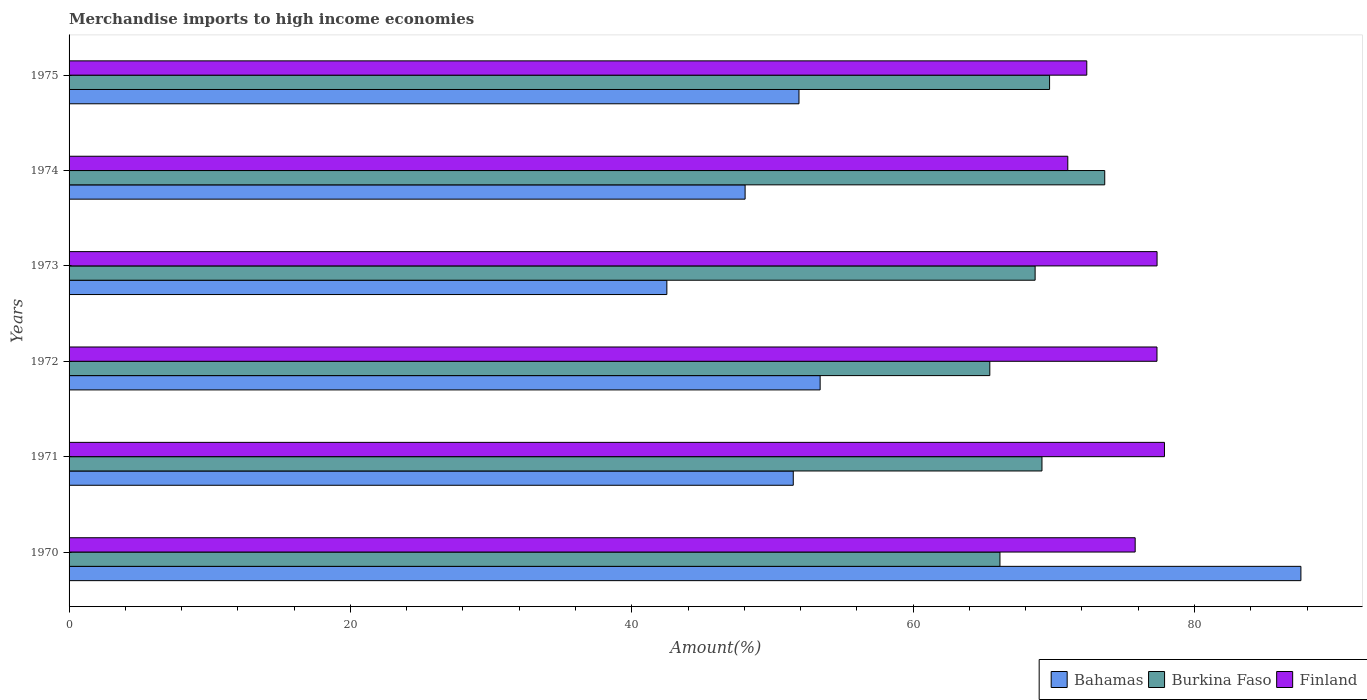How many different coloured bars are there?
Offer a terse response. 3. How many groups of bars are there?
Give a very brief answer. 6. What is the percentage of amount earned from merchandise imports in Bahamas in 1970?
Give a very brief answer. 87.57. Across all years, what is the maximum percentage of amount earned from merchandise imports in Bahamas?
Offer a terse response. 87.57. Across all years, what is the minimum percentage of amount earned from merchandise imports in Burkina Faso?
Offer a terse response. 65.45. In which year was the percentage of amount earned from merchandise imports in Finland maximum?
Keep it short and to the point. 1971. What is the total percentage of amount earned from merchandise imports in Finland in the graph?
Your answer should be very brief. 451.67. What is the difference between the percentage of amount earned from merchandise imports in Burkina Faso in 1973 and that in 1975?
Your answer should be compact. -1.03. What is the difference between the percentage of amount earned from merchandise imports in Burkina Faso in 1970 and the percentage of amount earned from merchandise imports in Finland in 1975?
Provide a short and direct response. -6.17. What is the average percentage of amount earned from merchandise imports in Burkina Faso per year?
Offer a very short reply. 68.8. In the year 1974, what is the difference between the percentage of amount earned from merchandise imports in Finland and percentage of amount earned from merchandise imports in Bahamas?
Offer a very short reply. 22.94. What is the ratio of the percentage of amount earned from merchandise imports in Burkina Faso in 1973 to that in 1974?
Provide a succinct answer. 0.93. Is the difference between the percentage of amount earned from merchandise imports in Finland in 1970 and 1973 greater than the difference between the percentage of amount earned from merchandise imports in Bahamas in 1970 and 1973?
Provide a short and direct response. No. What is the difference between the highest and the second highest percentage of amount earned from merchandise imports in Bahamas?
Your response must be concise. 34.18. What is the difference between the highest and the lowest percentage of amount earned from merchandise imports in Burkina Faso?
Ensure brevity in your answer.  8.17. Is the sum of the percentage of amount earned from merchandise imports in Finland in 1971 and 1972 greater than the maximum percentage of amount earned from merchandise imports in Bahamas across all years?
Offer a terse response. Yes. What does the 1st bar from the top in 1971 represents?
Keep it short and to the point. Finland. How many bars are there?
Your answer should be compact. 18. Are all the bars in the graph horizontal?
Make the answer very short. Yes. How many years are there in the graph?
Provide a succinct answer. 6. What is the difference between two consecutive major ticks on the X-axis?
Provide a succinct answer. 20. Are the values on the major ticks of X-axis written in scientific E-notation?
Give a very brief answer. No. Does the graph contain grids?
Offer a terse response. No. Where does the legend appear in the graph?
Offer a terse response. Bottom right. How many legend labels are there?
Your response must be concise. 3. How are the legend labels stacked?
Offer a terse response. Horizontal. What is the title of the graph?
Make the answer very short. Merchandise imports to high income economies. Does "Zambia" appear as one of the legend labels in the graph?
Your answer should be very brief. No. What is the label or title of the X-axis?
Your response must be concise. Amount(%). What is the label or title of the Y-axis?
Keep it short and to the point. Years. What is the Amount(%) of Bahamas in 1970?
Make the answer very short. 87.57. What is the Amount(%) of Burkina Faso in 1970?
Offer a terse response. 66.17. What is the Amount(%) of Finland in 1970?
Keep it short and to the point. 75.79. What is the Amount(%) in Bahamas in 1971?
Your response must be concise. 51.48. What is the Amount(%) of Burkina Faso in 1971?
Offer a very short reply. 69.16. What is the Amount(%) in Finland in 1971?
Your answer should be very brief. 77.87. What is the Amount(%) of Bahamas in 1972?
Offer a very short reply. 53.39. What is the Amount(%) in Burkina Faso in 1972?
Make the answer very short. 65.45. What is the Amount(%) of Finland in 1972?
Give a very brief answer. 77.34. What is the Amount(%) of Bahamas in 1973?
Make the answer very short. 42.49. What is the Amount(%) of Burkina Faso in 1973?
Make the answer very short. 68.67. What is the Amount(%) of Finland in 1973?
Your answer should be compact. 77.34. What is the Amount(%) of Bahamas in 1974?
Give a very brief answer. 48.06. What is the Amount(%) in Burkina Faso in 1974?
Your response must be concise. 73.62. What is the Amount(%) of Finland in 1974?
Ensure brevity in your answer.  71. What is the Amount(%) of Bahamas in 1975?
Give a very brief answer. 51.89. What is the Amount(%) in Burkina Faso in 1975?
Your answer should be compact. 69.7. What is the Amount(%) in Finland in 1975?
Offer a very short reply. 72.35. Across all years, what is the maximum Amount(%) of Bahamas?
Provide a succinct answer. 87.57. Across all years, what is the maximum Amount(%) in Burkina Faso?
Keep it short and to the point. 73.62. Across all years, what is the maximum Amount(%) in Finland?
Give a very brief answer. 77.87. Across all years, what is the minimum Amount(%) in Bahamas?
Provide a short and direct response. 42.49. Across all years, what is the minimum Amount(%) of Burkina Faso?
Give a very brief answer. 65.45. Across all years, what is the minimum Amount(%) in Finland?
Keep it short and to the point. 71. What is the total Amount(%) of Bahamas in the graph?
Your answer should be compact. 334.87. What is the total Amount(%) in Burkina Faso in the graph?
Ensure brevity in your answer.  412.78. What is the total Amount(%) in Finland in the graph?
Your answer should be compact. 451.67. What is the difference between the Amount(%) of Bahamas in 1970 and that in 1971?
Your answer should be compact. 36.09. What is the difference between the Amount(%) of Burkina Faso in 1970 and that in 1971?
Provide a succinct answer. -2.99. What is the difference between the Amount(%) of Finland in 1970 and that in 1971?
Offer a very short reply. -2.08. What is the difference between the Amount(%) in Bahamas in 1970 and that in 1972?
Your response must be concise. 34.18. What is the difference between the Amount(%) of Burkina Faso in 1970 and that in 1972?
Offer a very short reply. 0.72. What is the difference between the Amount(%) in Finland in 1970 and that in 1972?
Your response must be concise. -1.55. What is the difference between the Amount(%) in Bahamas in 1970 and that in 1973?
Make the answer very short. 45.07. What is the difference between the Amount(%) in Burkina Faso in 1970 and that in 1973?
Ensure brevity in your answer.  -2.5. What is the difference between the Amount(%) in Finland in 1970 and that in 1973?
Offer a terse response. -1.56. What is the difference between the Amount(%) in Bahamas in 1970 and that in 1974?
Your answer should be compact. 39.51. What is the difference between the Amount(%) of Burkina Faso in 1970 and that in 1974?
Your response must be concise. -7.45. What is the difference between the Amount(%) in Finland in 1970 and that in 1974?
Give a very brief answer. 4.79. What is the difference between the Amount(%) in Bahamas in 1970 and that in 1975?
Offer a very short reply. 35.68. What is the difference between the Amount(%) of Burkina Faso in 1970 and that in 1975?
Provide a short and direct response. -3.53. What is the difference between the Amount(%) of Finland in 1970 and that in 1975?
Keep it short and to the point. 3.44. What is the difference between the Amount(%) of Bahamas in 1971 and that in 1972?
Make the answer very short. -1.91. What is the difference between the Amount(%) of Burkina Faso in 1971 and that in 1972?
Make the answer very short. 3.71. What is the difference between the Amount(%) in Finland in 1971 and that in 1972?
Offer a very short reply. 0.53. What is the difference between the Amount(%) in Bahamas in 1971 and that in 1973?
Offer a very short reply. 8.99. What is the difference between the Amount(%) in Burkina Faso in 1971 and that in 1973?
Your response must be concise. 0.49. What is the difference between the Amount(%) in Finland in 1971 and that in 1973?
Give a very brief answer. 0.53. What is the difference between the Amount(%) of Bahamas in 1971 and that in 1974?
Provide a short and direct response. 3.42. What is the difference between the Amount(%) in Burkina Faso in 1971 and that in 1974?
Give a very brief answer. -4.46. What is the difference between the Amount(%) of Finland in 1971 and that in 1974?
Ensure brevity in your answer.  6.87. What is the difference between the Amount(%) in Bahamas in 1971 and that in 1975?
Offer a terse response. -0.41. What is the difference between the Amount(%) of Burkina Faso in 1971 and that in 1975?
Your response must be concise. -0.54. What is the difference between the Amount(%) of Finland in 1971 and that in 1975?
Ensure brevity in your answer.  5.52. What is the difference between the Amount(%) in Bahamas in 1972 and that in 1973?
Your response must be concise. 10.9. What is the difference between the Amount(%) of Burkina Faso in 1972 and that in 1973?
Ensure brevity in your answer.  -3.22. What is the difference between the Amount(%) in Finland in 1972 and that in 1973?
Your answer should be compact. -0.01. What is the difference between the Amount(%) of Bahamas in 1972 and that in 1974?
Offer a very short reply. 5.33. What is the difference between the Amount(%) in Burkina Faso in 1972 and that in 1974?
Offer a very short reply. -8.17. What is the difference between the Amount(%) of Finland in 1972 and that in 1974?
Keep it short and to the point. 6.34. What is the difference between the Amount(%) in Bahamas in 1972 and that in 1975?
Offer a very short reply. 1.5. What is the difference between the Amount(%) in Burkina Faso in 1972 and that in 1975?
Your answer should be compact. -4.25. What is the difference between the Amount(%) in Finland in 1972 and that in 1975?
Provide a short and direct response. 4.99. What is the difference between the Amount(%) of Bahamas in 1973 and that in 1974?
Provide a succinct answer. -5.56. What is the difference between the Amount(%) in Burkina Faso in 1973 and that in 1974?
Your answer should be compact. -4.95. What is the difference between the Amount(%) of Finland in 1973 and that in 1974?
Give a very brief answer. 6.35. What is the difference between the Amount(%) of Bahamas in 1973 and that in 1975?
Your answer should be very brief. -9.39. What is the difference between the Amount(%) in Burkina Faso in 1973 and that in 1975?
Your answer should be compact. -1.03. What is the difference between the Amount(%) in Finland in 1973 and that in 1975?
Your answer should be very brief. 5. What is the difference between the Amount(%) of Bahamas in 1974 and that in 1975?
Your response must be concise. -3.83. What is the difference between the Amount(%) in Burkina Faso in 1974 and that in 1975?
Make the answer very short. 3.92. What is the difference between the Amount(%) of Finland in 1974 and that in 1975?
Make the answer very short. -1.35. What is the difference between the Amount(%) in Bahamas in 1970 and the Amount(%) in Burkina Faso in 1971?
Provide a succinct answer. 18.41. What is the difference between the Amount(%) in Bahamas in 1970 and the Amount(%) in Finland in 1971?
Make the answer very short. 9.7. What is the difference between the Amount(%) in Burkina Faso in 1970 and the Amount(%) in Finland in 1971?
Keep it short and to the point. -11.69. What is the difference between the Amount(%) of Bahamas in 1970 and the Amount(%) of Burkina Faso in 1972?
Ensure brevity in your answer.  22.11. What is the difference between the Amount(%) of Bahamas in 1970 and the Amount(%) of Finland in 1972?
Keep it short and to the point. 10.23. What is the difference between the Amount(%) of Burkina Faso in 1970 and the Amount(%) of Finland in 1972?
Your answer should be compact. -11.16. What is the difference between the Amount(%) of Bahamas in 1970 and the Amount(%) of Burkina Faso in 1973?
Offer a terse response. 18.89. What is the difference between the Amount(%) in Bahamas in 1970 and the Amount(%) in Finland in 1973?
Give a very brief answer. 10.22. What is the difference between the Amount(%) in Burkina Faso in 1970 and the Amount(%) in Finland in 1973?
Give a very brief answer. -11.17. What is the difference between the Amount(%) of Bahamas in 1970 and the Amount(%) of Burkina Faso in 1974?
Your answer should be compact. 13.94. What is the difference between the Amount(%) of Bahamas in 1970 and the Amount(%) of Finland in 1974?
Make the answer very short. 16.57. What is the difference between the Amount(%) of Burkina Faso in 1970 and the Amount(%) of Finland in 1974?
Offer a terse response. -4.82. What is the difference between the Amount(%) of Bahamas in 1970 and the Amount(%) of Burkina Faso in 1975?
Ensure brevity in your answer.  17.87. What is the difference between the Amount(%) in Bahamas in 1970 and the Amount(%) in Finland in 1975?
Keep it short and to the point. 15.22. What is the difference between the Amount(%) of Burkina Faso in 1970 and the Amount(%) of Finland in 1975?
Provide a short and direct response. -6.17. What is the difference between the Amount(%) in Bahamas in 1971 and the Amount(%) in Burkina Faso in 1972?
Ensure brevity in your answer.  -13.97. What is the difference between the Amount(%) of Bahamas in 1971 and the Amount(%) of Finland in 1972?
Your answer should be compact. -25.86. What is the difference between the Amount(%) in Burkina Faso in 1971 and the Amount(%) in Finland in 1972?
Offer a terse response. -8.18. What is the difference between the Amount(%) of Bahamas in 1971 and the Amount(%) of Burkina Faso in 1973?
Your answer should be compact. -17.19. What is the difference between the Amount(%) of Bahamas in 1971 and the Amount(%) of Finland in 1973?
Your answer should be very brief. -25.86. What is the difference between the Amount(%) of Burkina Faso in 1971 and the Amount(%) of Finland in 1973?
Keep it short and to the point. -8.18. What is the difference between the Amount(%) of Bahamas in 1971 and the Amount(%) of Burkina Faso in 1974?
Provide a succinct answer. -22.14. What is the difference between the Amount(%) of Bahamas in 1971 and the Amount(%) of Finland in 1974?
Make the answer very short. -19.52. What is the difference between the Amount(%) in Burkina Faso in 1971 and the Amount(%) in Finland in 1974?
Provide a short and direct response. -1.84. What is the difference between the Amount(%) in Bahamas in 1971 and the Amount(%) in Burkina Faso in 1975?
Your answer should be compact. -18.22. What is the difference between the Amount(%) of Bahamas in 1971 and the Amount(%) of Finland in 1975?
Make the answer very short. -20.87. What is the difference between the Amount(%) of Burkina Faso in 1971 and the Amount(%) of Finland in 1975?
Offer a terse response. -3.19. What is the difference between the Amount(%) in Bahamas in 1972 and the Amount(%) in Burkina Faso in 1973?
Give a very brief answer. -15.28. What is the difference between the Amount(%) in Bahamas in 1972 and the Amount(%) in Finland in 1973?
Provide a short and direct response. -23.95. What is the difference between the Amount(%) of Burkina Faso in 1972 and the Amount(%) of Finland in 1973?
Make the answer very short. -11.89. What is the difference between the Amount(%) of Bahamas in 1972 and the Amount(%) of Burkina Faso in 1974?
Ensure brevity in your answer.  -20.23. What is the difference between the Amount(%) of Bahamas in 1972 and the Amount(%) of Finland in 1974?
Offer a very short reply. -17.6. What is the difference between the Amount(%) of Burkina Faso in 1972 and the Amount(%) of Finland in 1974?
Your response must be concise. -5.54. What is the difference between the Amount(%) in Bahamas in 1972 and the Amount(%) in Burkina Faso in 1975?
Your answer should be very brief. -16.31. What is the difference between the Amount(%) of Bahamas in 1972 and the Amount(%) of Finland in 1975?
Your answer should be compact. -18.95. What is the difference between the Amount(%) in Burkina Faso in 1972 and the Amount(%) in Finland in 1975?
Give a very brief answer. -6.89. What is the difference between the Amount(%) in Bahamas in 1973 and the Amount(%) in Burkina Faso in 1974?
Offer a very short reply. -31.13. What is the difference between the Amount(%) of Bahamas in 1973 and the Amount(%) of Finland in 1974?
Keep it short and to the point. -28.5. What is the difference between the Amount(%) of Burkina Faso in 1973 and the Amount(%) of Finland in 1974?
Offer a terse response. -2.32. What is the difference between the Amount(%) of Bahamas in 1973 and the Amount(%) of Burkina Faso in 1975?
Give a very brief answer. -27.21. What is the difference between the Amount(%) of Bahamas in 1973 and the Amount(%) of Finland in 1975?
Provide a succinct answer. -29.85. What is the difference between the Amount(%) in Burkina Faso in 1973 and the Amount(%) in Finland in 1975?
Ensure brevity in your answer.  -3.67. What is the difference between the Amount(%) of Bahamas in 1974 and the Amount(%) of Burkina Faso in 1975?
Offer a terse response. -21.64. What is the difference between the Amount(%) of Bahamas in 1974 and the Amount(%) of Finland in 1975?
Give a very brief answer. -24.29. What is the difference between the Amount(%) of Burkina Faso in 1974 and the Amount(%) of Finland in 1975?
Make the answer very short. 1.28. What is the average Amount(%) of Bahamas per year?
Offer a terse response. 55.81. What is the average Amount(%) of Burkina Faso per year?
Your response must be concise. 68.8. What is the average Amount(%) of Finland per year?
Your answer should be very brief. 75.28. In the year 1970, what is the difference between the Amount(%) of Bahamas and Amount(%) of Burkina Faso?
Provide a short and direct response. 21.39. In the year 1970, what is the difference between the Amount(%) of Bahamas and Amount(%) of Finland?
Your answer should be compact. 11.78. In the year 1970, what is the difference between the Amount(%) of Burkina Faso and Amount(%) of Finland?
Keep it short and to the point. -9.61. In the year 1971, what is the difference between the Amount(%) of Bahamas and Amount(%) of Burkina Faso?
Make the answer very short. -17.68. In the year 1971, what is the difference between the Amount(%) of Bahamas and Amount(%) of Finland?
Your response must be concise. -26.39. In the year 1971, what is the difference between the Amount(%) in Burkina Faso and Amount(%) in Finland?
Provide a succinct answer. -8.71. In the year 1972, what is the difference between the Amount(%) of Bahamas and Amount(%) of Burkina Faso?
Make the answer very short. -12.06. In the year 1972, what is the difference between the Amount(%) of Bahamas and Amount(%) of Finland?
Offer a terse response. -23.95. In the year 1972, what is the difference between the Amount(%) in Burkina Faso and Amount(%) in Finland?
Your answer should be very brief. -11.88. In the year 1973, what is the difference between the Amount(%) in Bahamas and Amount(%) in Burkina Faso?
Offer a very short reply. -26.18. In the year 1973, what is the difference between the Amount(%) in Bahamas and Amount(%) in Finland?
Offer a very short reply. -34.85. In the year 1973, what is the difference between the Amount(%) in Burkina Faso and Amount(%) in Finland?
Provide a succinct answer. -8.67. In the year 1974, what is the difference between the Amount(%) in Bahamas and Amount(%) in Burkina Faso?
Your answer should be very brief. -25.56. In the year 1974, what is the difference between the Amount(%) of Bahamas and Amount(%) of Finland?
Offer a terse response. -22.94. In the year 1974, what is the difference between the Amount(%) in Burkina Faso and Amount(%) in Finland?
Your response must be concise. 2.63. In the year 1975, what is the difference between the Amount(%) in Bahamas and Amount(%) in Burkina Faso?
Make the answer very short. -17.81. In the year 1975, what is the difference between the Amount(%) of Bahamas and Amount(%) of Finland?
Ensure brevity in your answer.  -20.46. In the year 1975, what is the difference between the Amount(%) of Burkina Faso and Amount(%) of Finland?
Keep it short and to the point. -2.64. What is the ratio of the Amount(%) of Bahamas in 1970 to that in 1971?
Give a very brief answer. 1.7. What is the ratio of the Amount(%) in Burkina Faso in 1970 to that in 1971?
Offer a terse response. 0.96. What is the ratio of the Amount(%) of Finland in 1970 to that in 1971?
Your answer should be compact. 0.97. What is the ratio of the Amount(%) in Bahamas in 1970 to that in 1972?
Your answer should be very brief. 1.64. What is the ratio of the Amount(%) in Finland in 1970 to that in 1972?
Your answer should be very brief. 0.98. What is the ratio of the Amount(%) of Bahamas in 1970 to that in 1973?
Give a very brief answer. 2.06. What is the ratio of the Amount(%) in Burkina Faso in 1970 to that in 1973?
Offer a very short reply. 0.96. What is the ratio of the Amount(%) of Finland in 1970 to that in 1973?
Ensure brevity in your answer.  0.98. What is the ratio of the Amount(%) in Bahamas in 1970 to that in 1974?
Offer a terse response. 1.82. What is the ratio of the Amount(%) in Burkina Faso in 1970 to that in 1974?
Keep it short and to the point. 0.9. What is the ratio of the Amount(%) of Finland in 1970 to that in 1974?
Give a very brief answer. 1.07. What is the ratio of the Amount(%) in Bahamas in 1970 to that in 1975?
Keep it short and to the point. 1.69. What is the ratio of the Amount(%) of Burkina Faso in 1970 to that in 1975?
Your answer should be compact. 0.95. What is the ratio of the Amount(%) of Finland in 1970 to that in 1975?
Offer a very short reply. 1.05. What is the ratio of the Amount(%) of Bahamas in 1971 to that in 1972?
Offer a very short reply. 0.96. What is the ratio of the Amount(%) of Burkina Faso in 1971 to that in 1972?
Make the answer very short. 1.06. What is the ratio of the Amount(%) of Bahamas in 1971 to that in 1973?
Provide a succinct answer. 1.21. What is the ratio of the Amount(%) of Burkina Faso in 1971 to that in 1973?
Provide a succinct answer. 1.01. What is the ratio of the Amount(%) of Finland in 1971 to that in 1973?
Provide a succinct answer. 1.01. What is the ratio of the Amount(%) in Bahamas in 1971 to that in 1974?
Ensure brevity in your answer.  1.07. What is the ratio of the Amount(%) in Burkina Faso in 1971 to that in 1974?
Offer a terse response. 0.94. What is the ratio of the Amount(%) in Finland in 1971 to that in 1974?
Your answer should be compact. 1.1. What is the ratio of the Amount(%) in Burkina Faso in 1971 to that in 1975?
Your answer should be very brief. 0.99. What is the ratio of the Amount(%) of Finland in 1971 to that in 1975?
Offer a terse response. 1.08. What is the ratio of the Amount(%) in Bahamas in 1972 to that in 1973?
Offer a terse response. 1.26. What is the ratio of the Amount(%) in Burkina Faso in 1972 to that in 1973?
Provide a succinct answer. 0.95. What is the ratio of the Amount(%) in Bahamas in 1972 to that in 1974?
Offer a terse response. 1.11. What is the ratio of the Amount(%) of Burkina Faso in 1972 to that in 1974?
Offer a very short reply. 0.89. What is the ratio of the Amount(%) of Finland in 1972 to that in 1974?
Provide a succinct answer. 1.09. What is the ratio of the Amount(%) of Burkina Faso in 1972 to that in 1975?
Your answer should be compact. 0.94. What is the ratio of the Amount(%) in Finland in 1972 to that in 1975?
Offer a very short reply. 1.07. What is the ratio of the Amount(%) in Bahamas in 1973 to that in 1974?
Offer a terse response. 0.88. What is the ratio of the Amount(%) of Burkina Faso in 1973 to that in 1974?
Offer a terse response. 0.93. What is the ratio of the Amount(%) of Finland in 1973 to that in 1974?
Keep it short and to the point. 1.09. What is the ratio of the Amount(%) of Bahamas in 1973 to that in 1975?
Ensure brevity in your answer.  0.82. What is the ratio of the Amount(%) in Finland in 1973 to that in 1975?
Your answer should be very brief. 1.07. What is the ratio of the Amount(%) in Bahamas in 1974 to that in 1975?
Offer a terse response. 0.93. What is the ratio of the Amount(%) of Burkina Faso in 1974 to that in 1975?
Provide a short and direct response. 1.06. What is the ratio of the Amount(%) of Finland in 1974 to that in 1975?
Your answer should be very brief. 0.98. What is the difference between the highest and the second highest Amount(%) of Bahamas?
Your response must be concise. 34.18. What is the difference between the highest and the second highest Amount(%) in Burkina Faso?
Provide a short and direct response. 3.92. What is the difference between the highest and the second highest Amount(%) of Finland?
Ensure brevity in your answer.  0.53. What is the difference between the highest and the lowest Amount(%) of Bahamas?
Your answer should be compact. 45.07. What is the difference between the highest and the lowest Amount(%) of Burkina Faso?
Offer a terse response. 8.17. What is the difference between the highest and the lowest Amount(%) in Finland?
Your response must be concise. 6.87. 